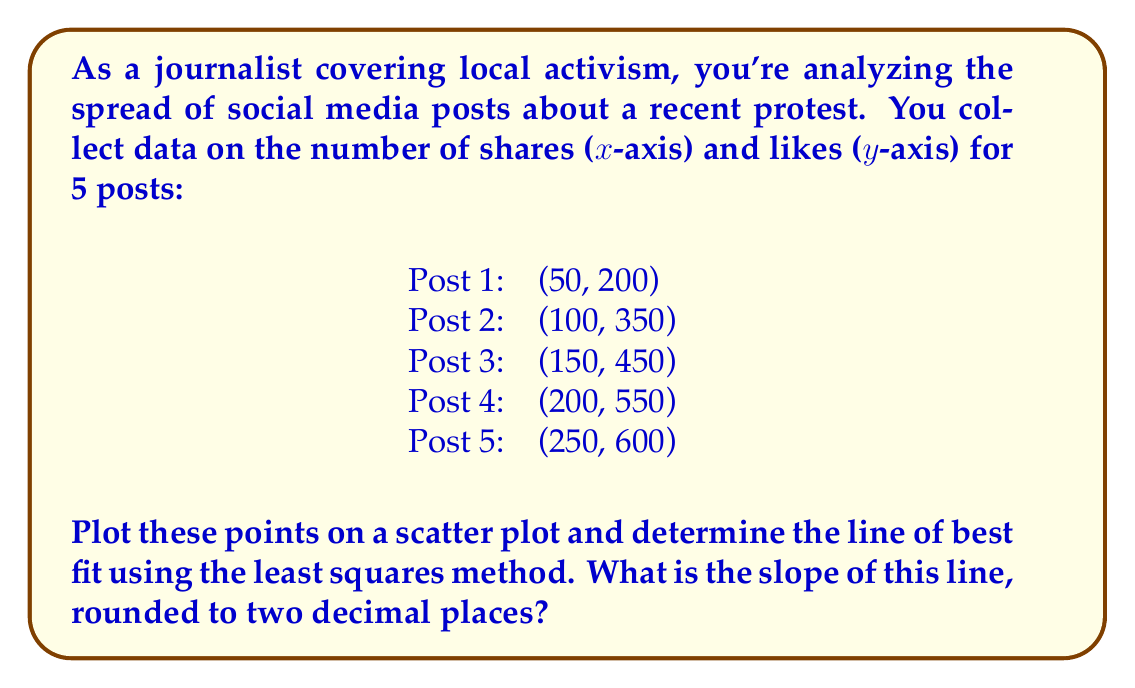Provide a solution to this math problem. To find the line of best fit using the least squares method, we need to calculate the slope (m) and y-intercept (b) of the line $y = mx + b$.

1. First, let's calculate the means of x and y:
   $\bar{x} = \frac{50 + 100 + 150 + 200 + 250}{5} = 150$
   $\bar{y} = \frac{200 + 350 + 450 + 550 + 600}{5} = 430$

2. Now, we'll use the formula for the slope:
   $$m = \frac{\sum(x_i - \bar{x})(y_i - \bar{y})}{\sum(x_i - \bar{x})^2}$$

3. Let's calculate the numerator and denominator separately:
   
   Numerator: 
   $(50-150)(200-430) + (100-150)(350-430) + (150-150)(450-430) + (200-150)(550-430) + (250-150)(600-430)$
   $= (-100)(-230) + (-50)(-80) + 0(20) + 50(120) + 100(170)$
   $= 23000 + 4000 + 0 + 6000 + 17000 = 50000$

   Denominator:
   $(50-150)^2 + (100-150)^2 + (150-150)^2 + (200-150)^2 + (250-150)^2$
   $= (-100)^2 + (-50)^2 + 0^2 + 50^2 + 100^2$
   $= 10000 + 2500 + 0 + 2500 + 10000 = 25000$

4. Now we can calculate the slope:
   $$m = \frac{50000}{25000} = 2$$

5. Rounding to two decimal places:
   $m = 2.00$
Answer: 2.00 